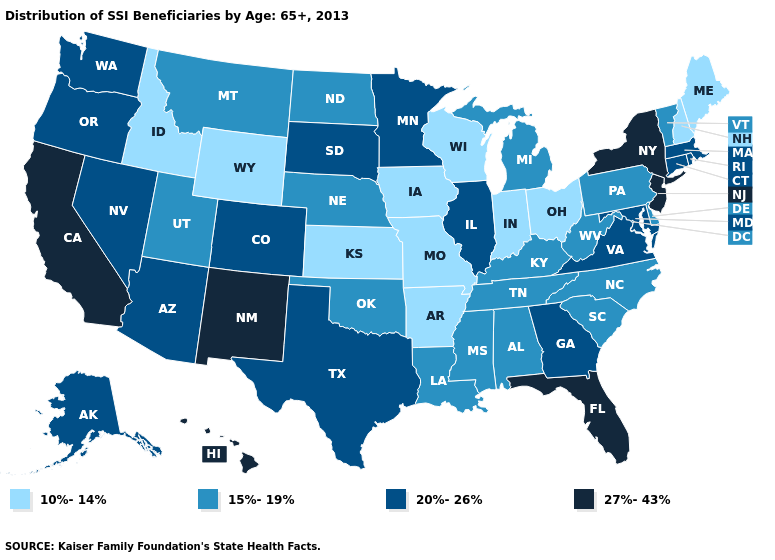Name the states that have a value in the range 15%-19%?
Quick response, please. Alabama, Delaware, Kentucky, Louisiana, Michigan, Mississippi, Montana, Nebraska, North Carolina, North Dakota, Oklahoma, Pennsylvania, South Carolina, Tennessee, Utah, Vermont, West Virginia. What is the value of Maine?
Concise answer only. 10%-14%. Does Oregon have the lowest value in the USA?
Give a very brief answer. No. What is the value of Rhode Island?
Concise answer only. 20%-26%. Does Massachusetts have a lower value than New Jersey?
Keep it brief. Yes. Name the states that have a value in the range 20%-26%?
Short answer required. Alaska, Arizona, Colorado, Connecticut, Georgia, Illinois, Maryland, Massachusetts, Minnesota, Nevada, Oregon, Rhode Island, South Dakota, Texas, Virginia, Washington. Does Washington have the lowest value in the USA?
Keep it brief. No. Name the states that have a value in the range 10%-14%?
Concise answer only. Arkansas, Idaho, Indiana, Iowa, Kansas, Maine, Missouri, New Hampshire, Ohio, Wisconsin, Wyoming. Does the first symbol in the legend represent the smallest category?
Give a very brief answer. Yes. What is the value of Arizona?
Keep it brief. 20%-26%. Name the states that have a value in the range 15%-19%?
Concise answer only. Alabama, Delaware, Kentucky, Louisiana, Michigan, Mississippi, Montana, Nebraska, North Carolina, North Dakota, Oklahoma, Pennsylvania, South Carolina, Tennessee, Utah, Vermont, West Virginia. Name the states that have a value in the range 20%-26%?
Concise answer only. Alaska, Arizona, Colorado, Connecticut, Georgia, Illinois, Maryland, Massachusetts, Minnesota, Nevada, Oregon, Rhode Island, South Dakota, Texas, Virginia, Washington. Name the states that have a value in the range 20%-26%?
Quick response, please. Alaska, Arizona, Colorado, Connecticut, Georgia, Illinois, Maryland, Massachusetts, Minnesota, Nevada, Oregon, Rhode Island, South Dakota, Texas, Virginia, Washington. Does the first symbol in the legend represent the smallest category?
Quick response, please. Yes. What is the highest value in the South ?
Short answer required. 27%-43%. 